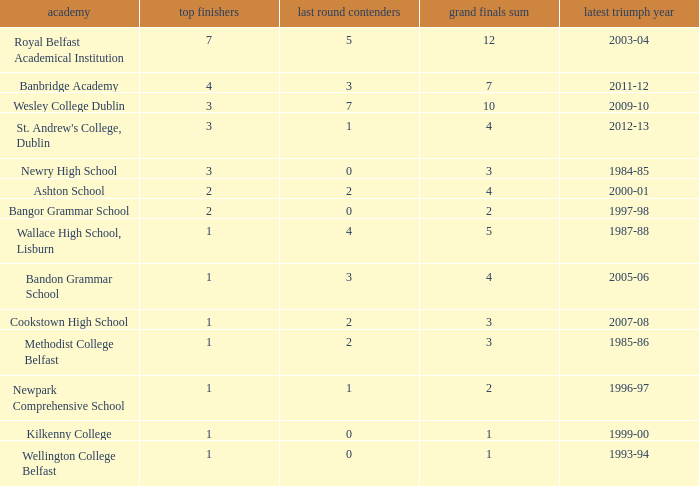How many times was banbridge academy the winner? 1.0. 